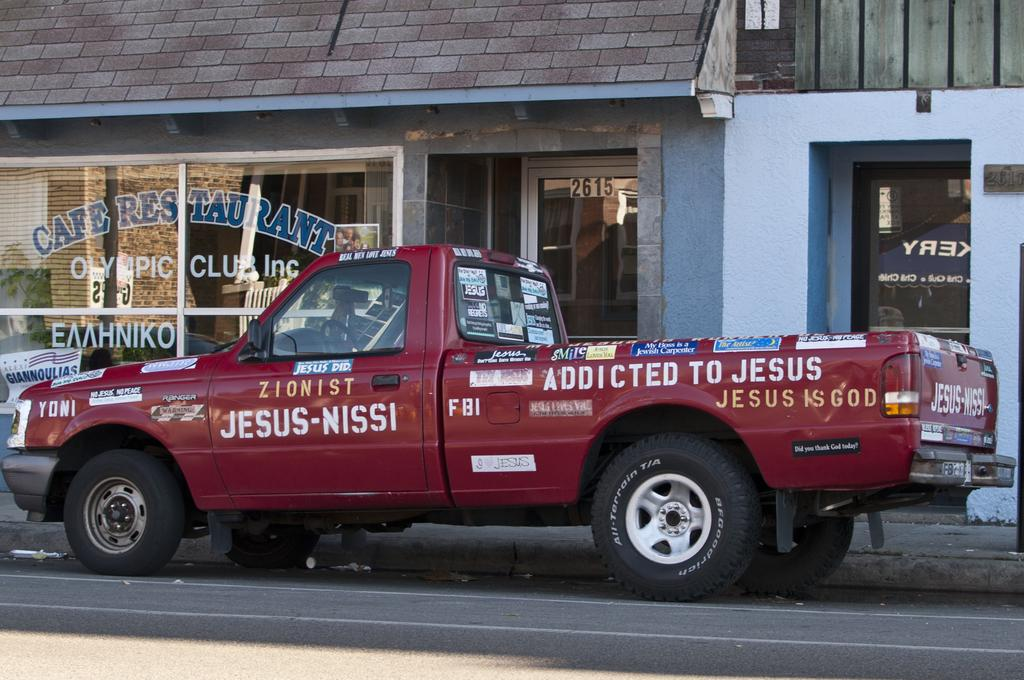What is the main subject in the foreground of the image? There is a vehicle on the road in the image. What can be seen in the background of the image? There is a house, a door, texts on the glass, a roof, and other objects visible in the background of the image. What type of jelly can be seen on the seashore in the image? There is no jelly or seashore present in the image. What committee is meeting in the background of the image? There is no committee meeting in the image; it only features a vehicle on the road and various elements in the background. 